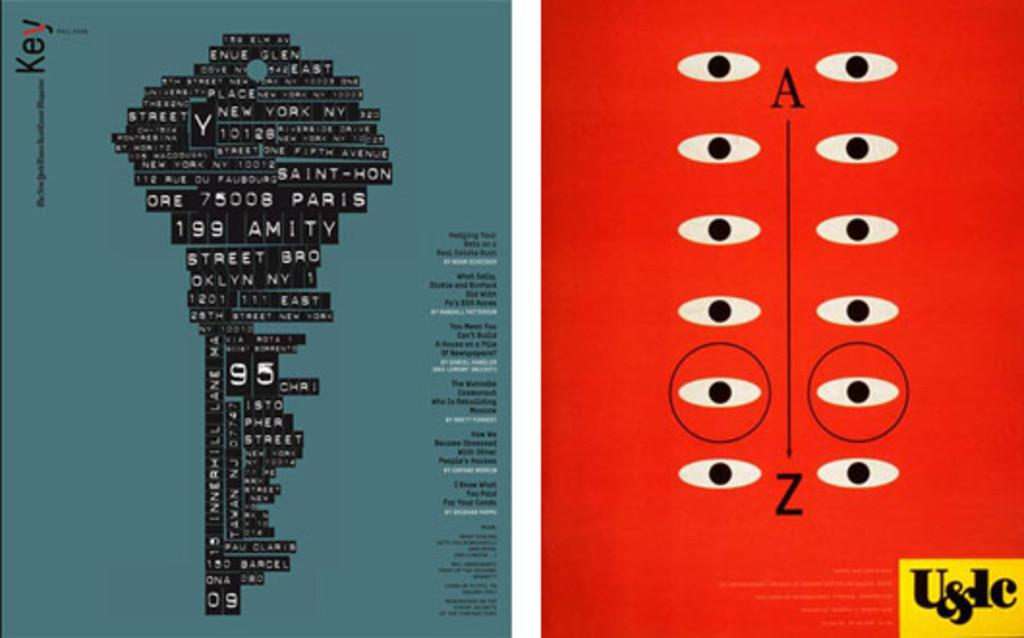<image>
Describe the image concisely. A cover with a key in blue and black is next to a red cover with eyes labeled U&lc. 